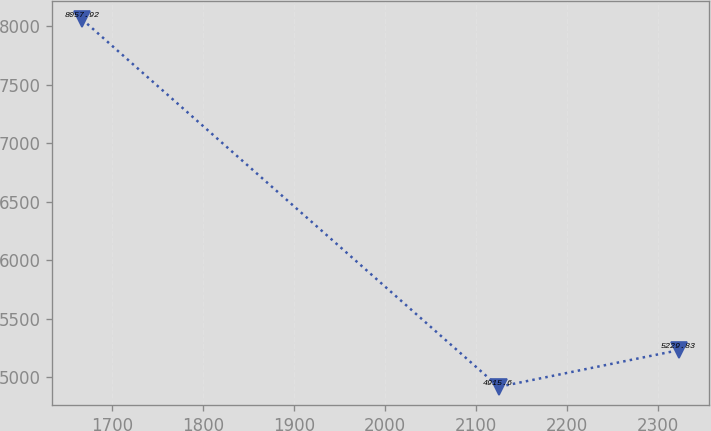Convert chart. <chart><loc_0><loc_0><loc_500><loc_500><line_chart><ecel><fcel>Unnamed: 1<nl><fcel>1667.28<fcel>8057.92<nl><fcel>2124.95<fcel>4915.6<nl><fcel>2323.2<fcel>5229.83<nl></chart> 